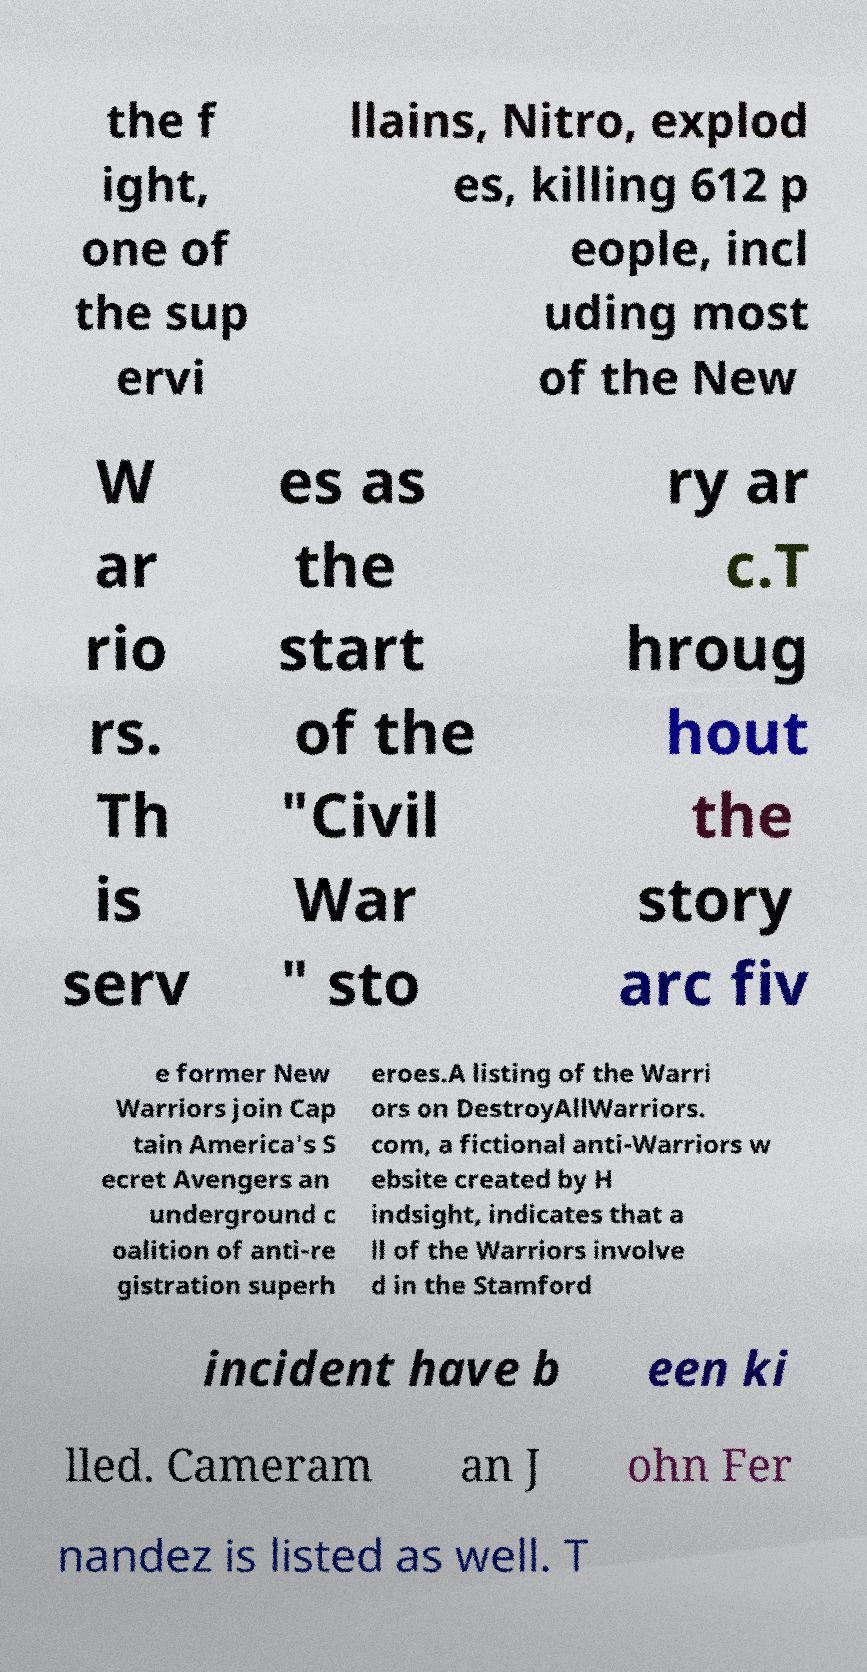Could you assist in decoding the text presented in this image and type it out clearly? the f ight, one of the sup ervi llains, Nitro, explod es, killing 612 p eople, incl uding most of the New W ar rio rs. Th is serv es as the start of the "Civil War " sto ry ar c.T hroug hout the story arc fiv e former New Warriors join Cap tain America's S ecret Avengers an underground c oalition of anti-re gistration superh eroes.A listing of the Warri ors on DestroyAllWarriors. com, a fictional anti-Warriors w ebsite created by H indsight, indicates that a ll of the Warriors involve d in the Stamford incident have b een ki lled. Cameram an J ohn Fer nandez is listed as well. T 